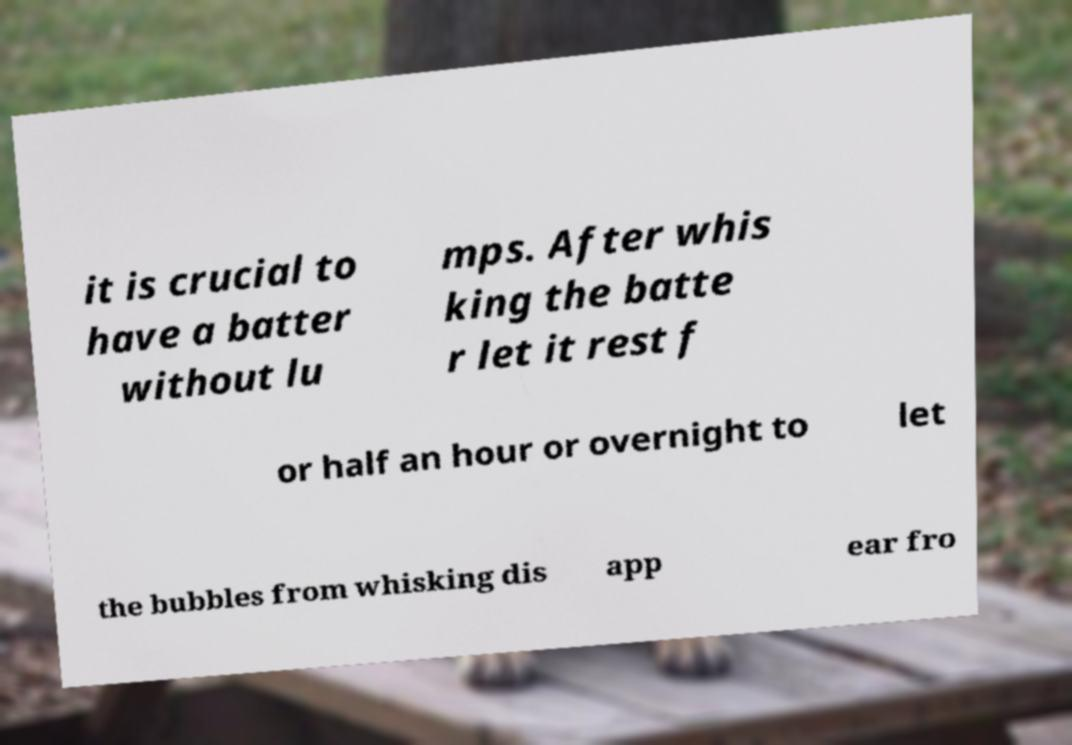Can you accurately transcribe the text from the provided image for me? it is crucial to have a batter without lu mps. After whis king the batte r let it rest f or half an hour or overnight to let the bubbles from whisking dis app ear fro 